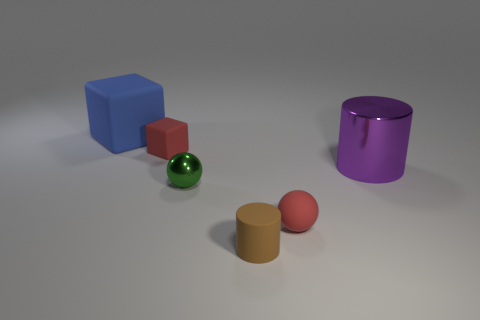What material is the large blue cube?
Keep it short and to the point. Rubber. Is there any other thing that has the same color as the metallic cylinder?
Offer a very short reply. No. Is the purple object made of the same material as the green object?
Give a very brief answer. Yes. What number of large metal things are to the right of the cube in front of the big thing behind the large purple object?
Your answer should be compact. 1. How many big cyan objects are there?
Your answer should be very brief. 0. Is the number of spheres that are in front of the small cylinder less than the number of blue rubber things in front of the small red block?
Your response must be concise. No. Are there fewer big objects to the right of the tiny matte sphere than blue metal balls?
Give a very brief answer. No. There is a block that is on the right side of the object left of the small rubber thing that is left of the green shiny sphere; what is its material?
Your answer should be very brief. Rubber. What number of objects are either small red matte objects that are to the left of the tiny brown object or small balls to the right of the green metallic thing?
Give a very brief answer. 2. There is another thing that is the same shape as the tiny green shiny object; what is its material?
Make the answer very short. Rubber. 